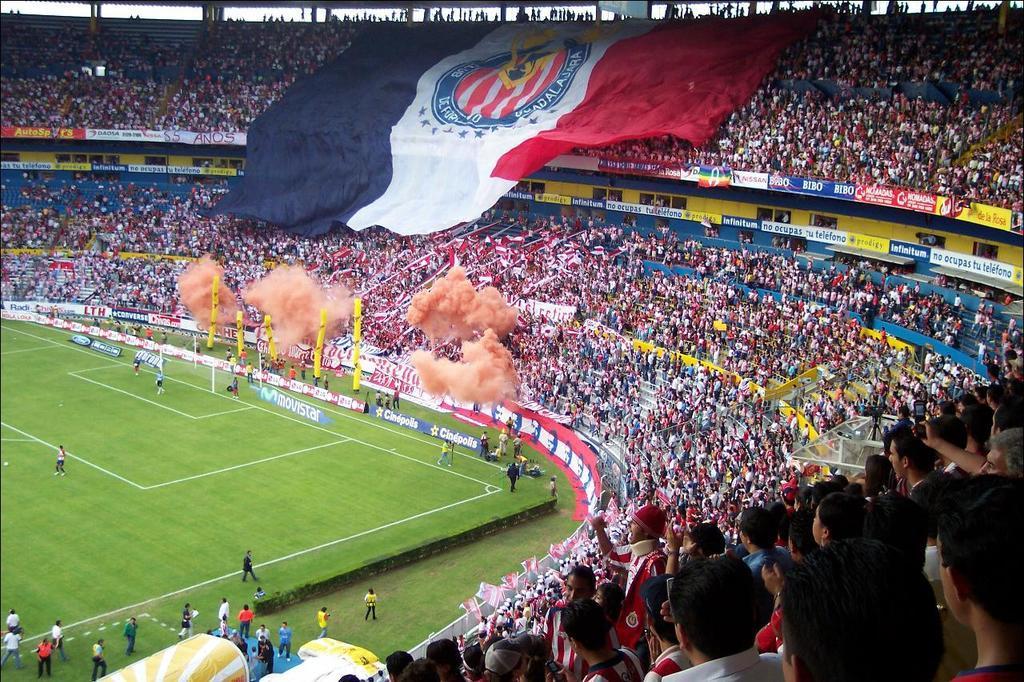Please provide a concise description of this image. In the image we can see there are people standing on the ground and the ground is covered with grass and there are spectators sitting on the chairs. There is a flag on the top. 